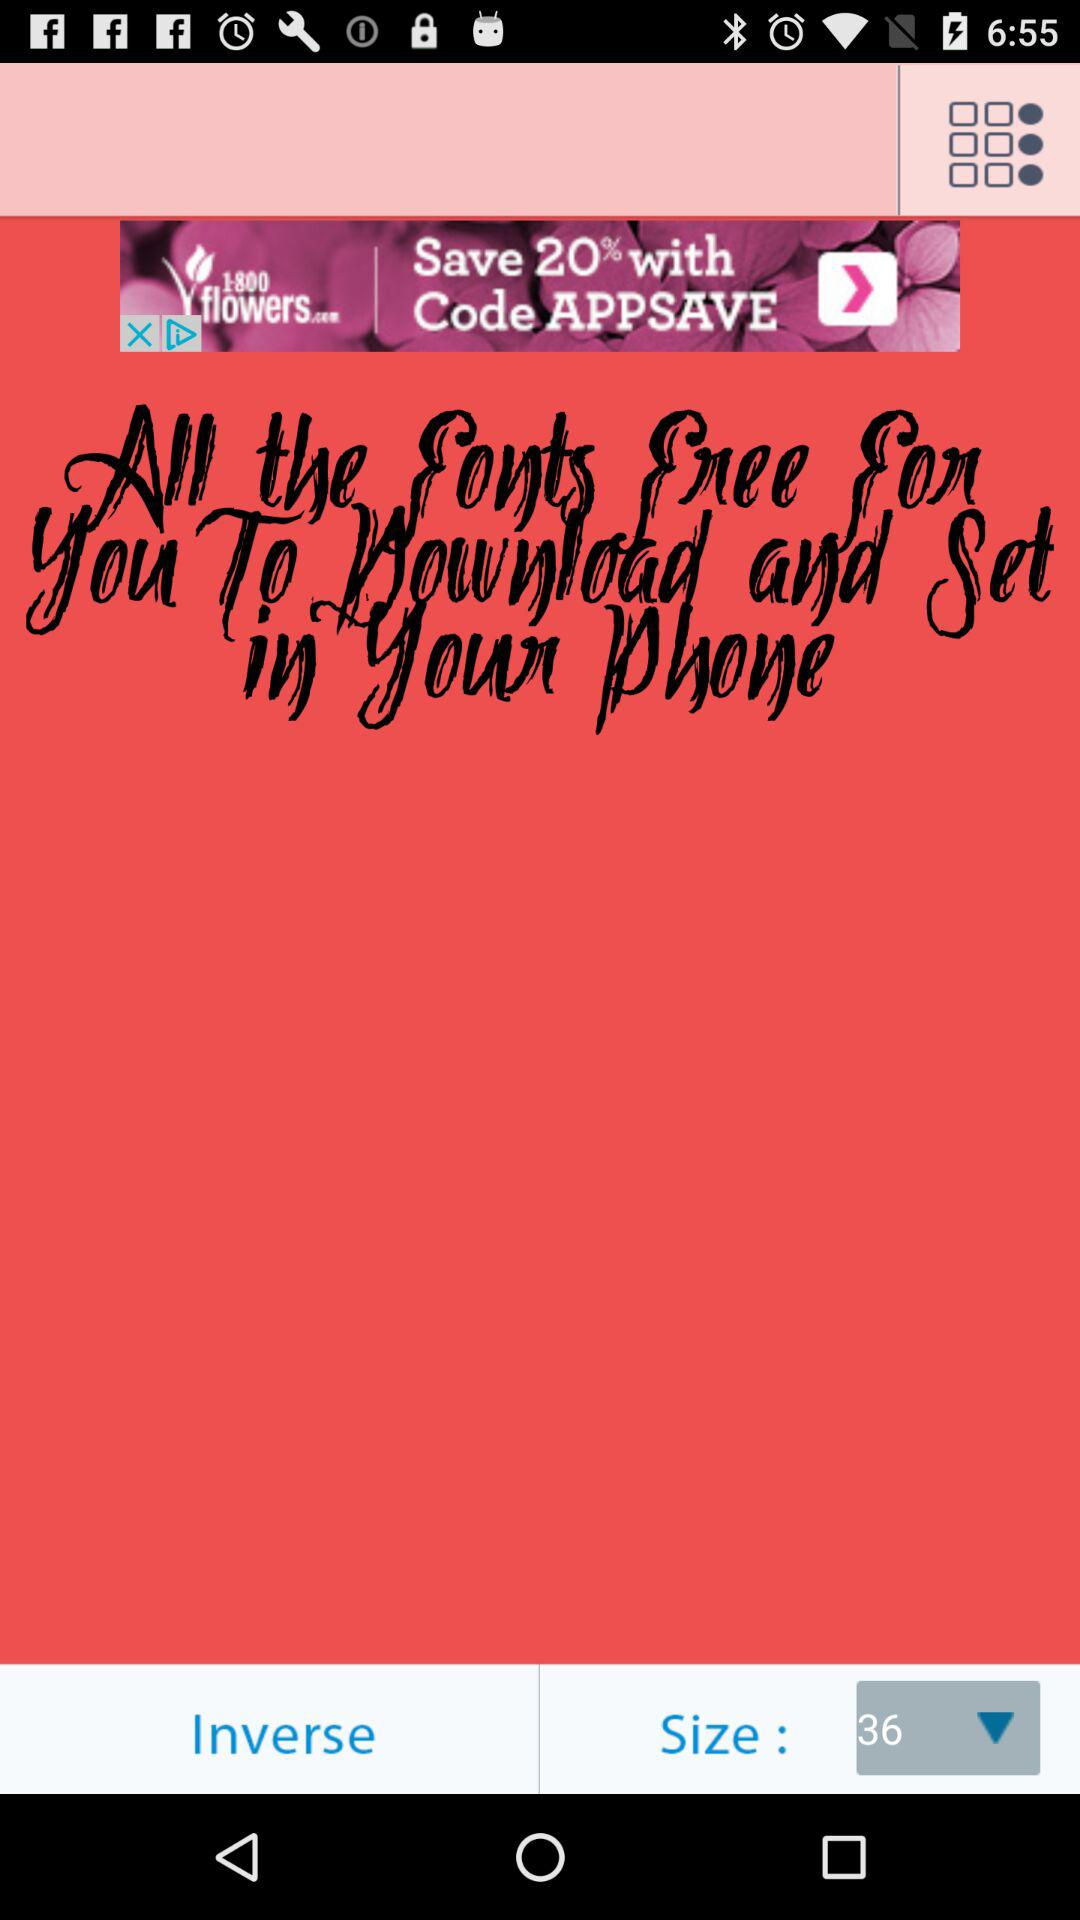What is the font size? The font size is 36. 